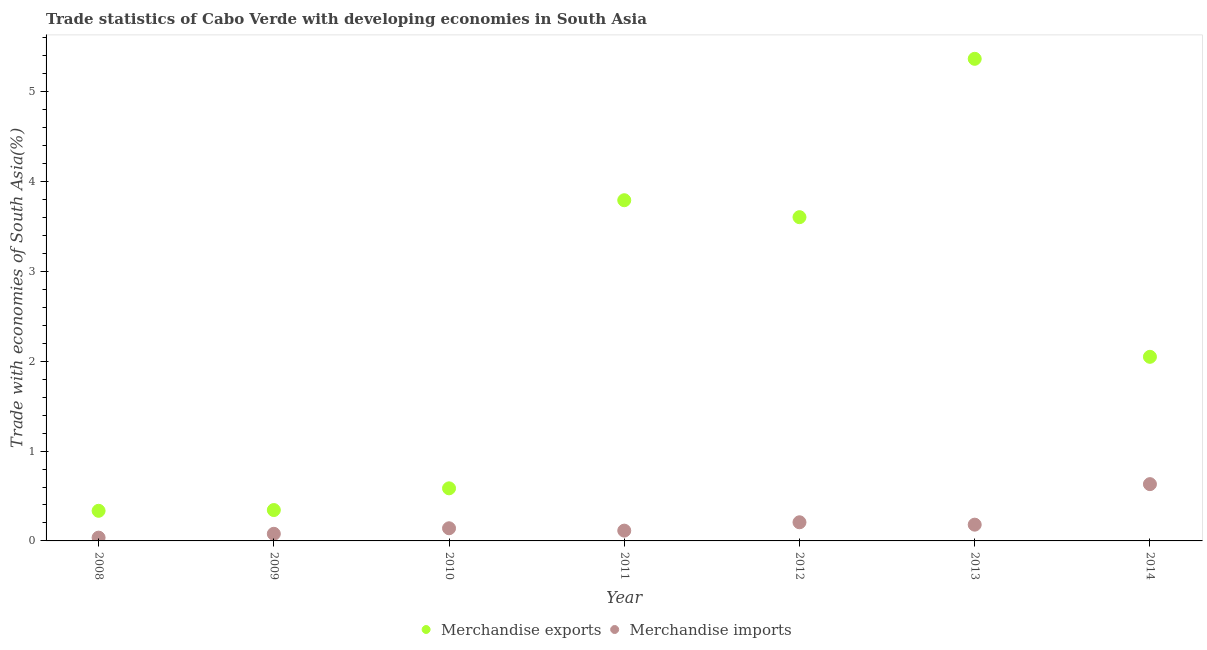What is the merchandise imports in 2014?
Keep it short and to the point. 0.63. Across all years, what is the maximum merchandise exports?
Offer a terse response. 5.37. Across all years, what is the minimum merchandise imports?
Make the answer very short. 0.04. In which year was the merchandise imports minimum?
Make the answer very short. 2008. What is the total merchandise exports in the graph?
Your answer should be very brief. 16.08. What is the difference between the merchandise imports in 2008 and that in 2012?
Offer a terse response. -0.17. What is the difference between the merchandise exports in 2014 and the merchandise imports in 2009?
Give a very brief answer. 1.97. What is the average merchandise exports per year?
Provide a succinct answer. 2.3. In the year 2011, what is the difference between the merchandise exports and merchandise imports?
Offer a very short reply. 3.68. In how many years, is the merchandise exports greater than 3.4 %?
Give a very brief answer. 3. What is the ratio of the merchandise exports in 2008 to that in 2009?
Make the answer very short. 0.98. What is the difference between the highest and the second highest merchandise imports?
Your answer should be compact. 0.42. What is the difference between the highest and the lowest merchandise exports?
Offer a terse response. 5.03. Is the sum of the merchandise exports in 2009 and 2014 greater than the maximum merchandise imports across all years?
Make the answer very short. Yes. Is the merchandise imports strictly greater than the merchandise exports over the years?
Your answer should be compact. No. Is the merchandise exports strictly less than the merchandise imports over the years?
Keep it short and to the point. No. Are the values on the major ticks of Y-axis written in scientific E-notation?
Offer a very short reply. No. Does the graph contain any zero values?
Ensure brevity in your answer.  No. Does the graph contain grids?
Your answer should be very brief. No. Where does the legend appear in the graph?
Provide a short and direct response. Bottom center. How many legend labels are there?
Offer a very short reply. 2. How are the legend labels stacked?
Provide a short and direct response. Horizontal. What is the title of the graph?
Your answer should be compact. Trade statistics of Cabo Verde with developing economies in South Asia. What is the label or title of the Y-axis?
Your response must be concise. Trade with economies of South Asia(%). What is the Trade with economies of South Asia(%) of Merchandise exports in 2008?
Keep it short and to the point. 0.34. What is the Trade with economies of South Asia(%) in Merchandise imports in 2008?
Your response must be concise. 0.04. What is the Trade with economies of South Asia(%) in Merchandise exports in 2009?
Provide a short and direct response. 0.34. What is the Trade with economies of South Asia(%) in Merchandise imports in 2009?
Give a very brief answer. 0.08. What is the Trade with economies of South Asia(%) in Merchandise exports in 2010?
Your answer should be very brief. 0.59. What is the Trade with economies of South Asia(%) in Merchandise imports in 2010?
Give a very brief answer. 0.14. What is the Trade with economies of South Asia(%) in Merchandise exports in 2011?
Offer a very short reply. 3.79. What is the Trade with economies of South Asia(%) of Merchandise imports in 2011?
Make the answer very short. 0.11. What is the Trade with economies of South Asia(%) in Merchandise exports in 2012?
Your response must be concise. 3.6. What is the Trade with economies of South Asia(%) in Merchandise imports in 2012?
Your answer should be very brief. 0.21. What is the Trade with economies of South Asia(%) of Merchandise exports in 2013?
Your answer should be very brief. 5.37. What is the Trade with economies of South Asia(%) in Merchandise imports in 2013?
Provide a short and direct response. 0.18. What is the Trade with economies of South Asia(%) in Merchandise exports in 2014?
Your response must be concise. 2.05. What is the Trade with economies of South Asia(%) of Merchandise imports in 2014?
Offer a very short reply. 0.63. Across all years, what is the maximum Trade with economies of South Asia(%) in Merchandise exports?
Provide a short and direct response. 5.37. Across all years, what is the maximum Trade with economies of South Asia(%) in Merchandise imports?
Your answer should be compact. 0.63. Across all years, what is the minimum Trade with economies of South Asia(%) in Merchandise exports?
Give a very brief answer. 0.34. Across all years, what is the minimum Trade with economies of South Asia(%) of Merchandise imports?
Your answer should be compact. 0.04. What is the total Trade with economies of South Asia(%) in Merchandise exports in the graph?
Give a very brief answer. 16.08. What is the total Trade with economies of South Asia(%) of Merchandise imports in the graph?
Give a very brief answer. 1.39. What is the difference between the Trade with economies of South Asia(%) in Merchandise exports in 2008 and that in 2009?
Provide a short and direct response. -0.01. What is the difference between the Trade with economies of South Asia(%) of Merchandise imports in 2008 and that in 2009?
Offer a very short reply. -0.04. What is the difference between the Trade with economies of South Asia(%) of Merchandise imports in 2008 and that in 2010?
Your answer should be compact. -0.1. What is the difference between the Trade with economies of South Asia(%) of Merchandise exports in 2008 and that in 2011?
Keep it short and to the point. -3.46. What is the difference between the Trade with economies of South Asia(%) of Merchandise imports in 2008 and that in 2011?
Keep it short and to the point. -0.08. What is the difference between the Trade with economies of South Asia(%) in Merchandise exports in 2008 and that in 2012?
Provide a succinct answer. -3.27. What is the difference between the Trade with economies of South Asia(%) in Merchandise imports in 2008 and that in 2012?
Keep it short and to the point. -0.17. What is the difference between the Trade with economies of South Asia(%) of Merchandise exports in 2008 and that in 2013?
Your response must be concise. -5.03. What is the difference between the Trade with economies of South Asia(%) in Merchandise imports in 2008 and that in 2013?
Provide a short and direct response. -0.14. What is the difference between the Trade with economies of South Asia(%) of Merchandise exports in 2008 and that in 2014?
Make the answer very short. -1.71. What is the difference between the Trade with economies of South Asia(%) in Merchandise imports in 2008 and that in 2014?
Keep it short and to the point. -0.6. What is the difference between the Trade with economies of South Asia(%) in Merchandise exports in 2009 and that in 2010?
Offer a very short reply. -0.24. What is the difference between the Trade with economies of South Asia(%) of Merchandise imports in 2009 and that in 2010?
Your answer should be very brief. -0.06. What is the difference between the Trade with economies of South Asia(%) of Merchandise exports in 2009 and that in 2011?
Your answer should be compact. -3.45. What is the difference between the Trade with economies of South Asia(%) in Merchandise imports in 2009 and that in 2011?
Make the answer very short. -0.04. What is the difference between the Trade with economies of South Asia(%) in Merchandise exports in 2009 and that in 2012?
Your answer should be very brief. -3.26. What is the difference between the Trade with economies of South Asia(%) in Merchandise imports in 2009 and that in 2012?
Give a very brief answer. -0.13. What is the difference between the Trade with economies of South Asia(%) of Merchandise exports in 2009 and that in 2013?
Keep it short and to the point. -5.02. What is the difference between the Trade with economies of South Asia(%) in Merchandise imports in 2009 and that in 2013?
Make the answer very short. -0.1. What is the difference between the Trade with economies of South Asia(%) in Merchandise exports in 2009 and that in 2014?
Ensure brevity in your answer.  -1.71. What is the difference between the Trade with economies of South Asia(%) in Merchandise imports in 2009 and that in 2014?
Provide a short and direct response. -0.55. What is the difference between the Trade with economies of South Asia(%) of Merchandise exports in 2010 and that in 2011?
Your response must be concise. -3.21. What is the difference between the Trade with economies of South Asia(%) in Merchandise imports in 2010 and that in 2011?
Provide a short and direct response. 0.03. What is the difference between the Trade with economies of South Asia(%) in Merchandise exports in 2010 and that in 2012?
Offer a very short reply. -3.02. What is the difference between the Trade with economies of South Asia(%) in Merchandise imports in 2010 and that in 2012?
Provide a short and direct response. -0.07. What is the difference between the Trade with economies of South Asia(%) of Merchandise exports in 2010 and that in 2013?
Your answer should be compact. -4.78. What is the difference between the Trade with economies of South Asia(%) of Merchandise imports in 2010 and that in 2013?
Your answer should be very brief. -0.04. What is the difference between the Trade with economies of South Asia(%) of Merchandise exports in 2010 and that in 2014?
Provide a succinct answer. -1.46. What is the difference between the Trade with economies of South Asia(%) in Merchandise imports in 2010 and that in 2014?
Your response must be concise. -0.49. What is the difference between the Trade with economies of South Asia(%) in Merchandise exports in 2011 and that in 2012?
Provide a short and direct response. 0.19. What is the difference between the Trade with economies of South Asia(%) in Merchandise imports in 2011 and that in 2012?
Offer a very short reply. -0.09. What is the difference between the Trade with economies of South Asia(%) in Merchandise exports in 2011 and that in 2013?
Ensure brevity in your answer.  -1.57. What is the difference between the Trade with economies of South Asia(%) of Merchandise imports in 2011 and that in 2013?
Your answer should be compact. -0.07. What is the difference between the Trade with economies of South Asia(%) of Merchandise exports in 2011 and that in 2014?
Ensure brevity in your answer.  1.74. What is the difference between the Trade with economies of South Asia(%) of Merchandise imports in 2011 and that in 2014?
Make the answer very short. -0.52. What is the difference between the Trade with economies of South Asia(%) in Merchandise exports in 2012 and that in 2013?
Offer a very short reply. -1.76. What is the difference between the Trade with economies of South Asia(%) of Merchandise imports in 2012 and that in 2013?
Offer a terse response. 0.03. What is the difference between the Trade with economies of South Asia(%) in Merchandise exports in 2012 and that in 2014?
Your response must be concise. 1.55. What is the difference between the Trade with economies of South Asia(%) of Merchandise imports in 2012 and that in 2014?
Ensure brevity in your answer.  -0.42. What is the difference between the Trade with economies of South Asia(%) of Merchandise exports in 2013 and that in 2014?
Your answer should be very brief. 3.32. What is the difference between the Trade with economies of South Asia(%) of Merchandise imports in 2013 and that in 2014?
Offer a terse response. -0.45. What is the difference between the Trade with economies of South Asia(%) in Merchandise exports in 2008 and the Trade with economies of South Asia(%) in Merchandise imports in 2009?
Provide a short and direct response. 0.26. What is the difference between the Trade with economies of South Asia(%) of Merchandise exports in 2008 and the Trade with economies of South Asia(%) of Merchandise imports in 2010?
Ensure brevity in your answer.  0.19. What is the difference between the Trade with economies of South Asia(%) of Merchandise exports in 2008 and the Trade with economies of South Asia(%) of Merchandise imports in 2011?
Provide a short and direct response. 0.22. What is the difference between the Trade with economies of South Asia(%) in Merchandise exports in 2008 and the Trade with economies of South Asia(%) in Merchandise imports in 2012?
Your answer should be very brief. 0.13. What is the difference between the Trade with economies of South Asia(%) in Merchandise exports in 2008 and the Trade with economies of South Asia(%) in Merchandise imports in 2013?
Offer a terse response. 0.15. What is the difference between the Trade with economies of South Asia(%) in Merchandise exports in 2008 and the Trade with economies of South Asia(%) in Merchandise imports in 2014?
Your answer should be compact. -0.3. What is the difference between the Trade with economies of South Asia(%) in Merchandise exports in 2009 and the Trade with economies of South Asia(%) in Merchandise imports in 2010?
Your answer should be very brief. 0.2. What is the difference between the Trade with economies of South Asia(%) in Merchandise exports in 2009 and the Trade with economies of South Asia(%) in Merchandise imports in 2011?
Your answer should be very brief. 0.23. What is the difference between the Trade with economies of South Asia(%) of Merchandise exports in 2009 and the Trade with economies of South Asia(%) of Merchandise imports in 2012?
Provide a succinct answer. 0.14. What is the difference between the Trade with economies of South Asia(%) of Merchandise exports in 2009 and the Trade with economies of South Asia(%) of Merchandise imports in 2013?
Offer a terse response. 0.16. What is the difference between the Trade with economies of South Asia(%) in Merchandise exports in 2009 and the Trade with economies of South Asia(%) in Merchandise imports in 2014?
Give a very brief answer. -0.29. What is the difference between the Trade with economies of South Asia(%) of Merchandise exports in 2010 and the Trade with economies of South Asia(%) of Merchandise imports in 2011?
Provide a succinct answer. 0.47. What is the difference between the Trade with economies of South Asia(%) of Merchandise exports in 2010 and the Trade with economies of South Asia(%) of Merchandise imports in 2012?
Provide a short and direct response. 0.38. What is the difference between the Trade with economies of South Asia(%) in Merchandise exports in 2010 and the Trade with economies of South Asia(%) in Merchandise imports in 2013?
Provide a succinct answer. 0.4. What is the difference between the Trade with economies of South Asia(%) of Merchandise exports in 2010 and the Trade with economies of South Asia(%) of Merchandise imports in 2014?
Ensure brevity in your answer.  -0.05. What is the difference between the Trade with economies of South Asia(%) of Merchandise exports in 2011 and the Trade with economies of South Asia(%) of Merchandise imports in 2012?
Your answer should be compact. 3.58. What is the difference between the Trade with economies of South Asia(%) of Merchandise exports in 2011 and the Trade with economies of South Asia(%) of Merchandise imports in 2013?
Ensure brevity in your answer.  3.61. What is the difference between the Trade with economies of South Asia(%) of Merchandise exports in 2011 and the Trade with economies of South Asia(%) of Merchandise imports in 2014?
Give a very brief answer. 3.16. What is the difference between the Trade with economies of South Asia(%) in Merchandise exports in 2012 and the Trade with economies of South Asia(%) in Merchandise imports in 2013?
Keep it short and to the point. 3.42. What is the difference between the Trade with economies of South Asia(%) in Merchandise exports in 2012 and the Trade with economies of South Asia(%) in Merchandise imports in 2014?
Offer a terse response. 2.97. What is the difference between the Trade with economies of South Asia(%) of Merchandise exports in 2013 and the Trade with economies of South Asia(%) of Merchandise imports in 2014?
Offer a terse response. 4.73. What is the average Trade with economies of South Asia(%) in Merchandise exports per year?
Your response must be concise. 2.3. What is the average Trade with economies of South Asia(%) in Merchandise imports per year?
Give a very brief answer. 0.2. In the year 2008, what is the difference between the Trade with economies of South Asia(%) in Merchandise exports and Trade with economies of South Asia(%) in Merchandise imports?
Offer a very short reply. 0.3. In the year 2009, what is the difference between the Trade with economies of South Asia(%) in Merchandise exports and Trade with economies of South Asia(%) in Merchandise imports?
Give a very brief answer. 0.26. In the year 2010, what is the difference between the Trade with economies of South Asia(%) in Merchandise exports and Trade with economies of South Asia(%) in Merchandise imports?
Make the answer very short. 0.44. In the year 2011, what is the difference between the Trade with economies of South Asia(%) in Merchandise exports and Trade with economies of South Asia(%) in Merchandise imports?
Your answer should be compact. 3.68. In the year 2012, what is the difference between the Trade with economies of South Asia(%) in Merchandise exports and Trade with economies of South Asia(%) in Merchandise imports?
Ensure brevity in your answer.  3.4. In the year 2013, what is the difference between the Trade with economies of South Asia(%) of Merchandise exports and Trade with economies of South Asia(%) of Merchandise imports?
Make the answer very short. 5.19. In the year 2014, what is the difference between the Trade with economies of South Asia(%) of Merchandise exports and Trade with economies of South Asia(%) of Merchandise imports?
Keep it short and to the point. 1.42. What is the ratio of the Trade with economies of South Asia(%) of Merchandise exports in 2008 to that in 2009?
Your response must be concise. 0.98. What is the ratio of the Trade with economies of South Asia(%) of Merchandise imports in 2008 to that in 2009?
Give a very brief answer. 0.46. What is the ratio of the Trade with economies of South Asia(%) in Merchandise exports in 2008 to that in 2010?
Provide a succinct answer. 0.57. What is the ratio of the Trade with economies of South Asia(%) in Merchandise imports in 2008 to that in 2010?
Provide a short and direct response. 0.26. What is the ratio of the Trade with economies of South Asia(%) of Merchandise exports in 2008 to that in 2011?
Give a very brief answer. 0.09. What is the ratio of the Trade with economies of South Asia(%) in Merchandise imports in 2008 to that in 2011?
Offer a very short reply. 0.32. What is the ratio of the Trade with economies of South Asia(%) in Merchandise exports in 2008 to that in 2012?
Give a very brief answer. 0.09. What is the ratio of the Trade with economies of South Asia(%) of Merchandise imports in 2008 to that in 2012?
Your response must be concise. 0.18. What is the ratio of the Trade with economies of South Asia(%) in Merchandise exports in 2008 to that in 2013?
Your answer should be very brief. 0.06. What is the ratio of the Trade with economies of South Asia(%) of Merchandise imports in 2008 to that in 2013?
Provide a succinct answer. 0.2. What is the ratio of the Trade with economies of South Asia(%) in Merchandise exports in 2008 to that in 2014?
Ensure brevity in your answer.  0.16. What is the ratio of the Trade with economies of South Asia(%) in Merchandise imports in 2008 to that in 2014?
Offer a terse response. 0.06. What is the ratio of the Trade with economies of South Asia(%) of Merchandise exports in 2009 to that in 2010?
Your response must be concise. 0.59. What is the ratio of the Trade with economies of South Asia(%) in Merchandise imports in 2009 to that in 2010?
Your answer should be compact. 0.56. What is the ratio of the Trade with economies of South Asia(%) of Merchandise exports in 2009 to that in 2011?
Offer a very short reply. 0.09. What is the ratio of the Trade with economies of South Asia(%) in Merchandise imports in 2009 to that in 2011?
Offer a very short reply. 0.69. What is the ratio of the Trade with economies of South Asia(%) in Merchandise exports in 2009 to that in 2012?
Ensure brevity in your answer.  0.1. What is the ratio of the Trade with economies of South Asia(%) in Merchandise imports in 2009 to that in 2012?
Keep it short and to the point. 0.38. What is the ratio of the Trade with economies of South Asia(%) of Merchandise exports in 2009 to that in 2013?
Provide a short and direct response. 0.06. What is the ratio of the Trade with economies of South Asia(%) in Merchandise imports in 2009 to that in 2013?
Ensure brevity in your answer.  0.44. What is the ratio of the Trade with economies of South Asia(%) in Merchandise exports in 2009 to that in 2014?
Provide a succinct answer. 0.17. What is the ratio of the Trade with economies of South Asia(%) in Merchandise imports in 2009 to that in 2014?
Ensure brevity in your answer.  0.13. What is the ratio of the Trade with economies of South Asia(%) in Merchandise exports in 2010 to that in 2011?
Provide a succinct answer. 0.15. What is the ratio of the Trade with economies of South Asia(%) of Merchandise imports in 2010 to that in 2011?
Provide a short and direct response. 1.23. What is the ratio of the Trade with economies of South Asia(%) of Merchandise exports in 2010 to that in 2012?
Provide a short and direct response. 0.16. What is the ratio of the Trade with economies of South Asia(%) in Merchandise imports in 2010 to that in 2012?
Provide a short and direct response. 0.68. What is the ratio of the Trade with economies of South Asia(%) of Merchandise exports in 2010 to that in 2013?
Your answer should be very brief. 0.11. What is the ratio of the Trade with economies of South Asia(%) of Merchandise imports in 2010 to that in 2013?
Offer a terse response. 0.78. What is the ratio of the Trade with economies of South Asia(%) of Merchandise exports in 2010 to that in 2014?
Offer a terse response. 0.29. What is the ratio of the Trade with economies of South Asia(%) in Merchandise imports in 2010 to that in 2014?
Give a very brief answer. 0.22. What is the ratio of the Trade with economies of South Asia(%) in Merchandise exports in 2011 to that in 2012?
Your answer should be very brief. 1.05. What is the ratio of the Trade with economies of South Asia(%) of Merchandise imports in 2011 to that in 2012?
Offer a terse response. 0.55. What is the ratio of the Trade with economies of South Asia(%) of Merchandise exports in 2011 to that in 2013?
Keep it short and to the point. 0.71. What is the ratio of the Trade with economies of South Asia(%) of Merchandise imports in 2011 to that in 2013?
Offer a terse response. 0.63. What is the ratio of the Trade with economies of South Asia(%) of Merchandise exports in 2011 to that in 2014?
Provide a short and direct response. 1.85. What is the ratio of the Trade with economies of South Asia(%) in Merchandise imports in 2011 to that in 2014?
Offer a terse response. 0.18. What is the ratio of the Trade with economies of South Asia(%) in Merchandise exports in 2012 to that in 2013?
Provide a succinct answer. 0.67. What is the ratio of the Trade with economies of South Asia(%) in Merchandise imports in 2012 to that in 2013?
Offer a terse response. 1.15. What is the ratio of the Trade with economies of South Asia(%) of Merchandise exports in 2012 to that in 2014?
Offer a very short reply. 1.76. What is the ratio of the Trade with economies of South Asia(%) in Merchandise imports in 2012 to that in 2014?
Keep it short and to the point. 0.33. What is the ratio of the Trade with economies of South Asia(%) in Merchandise exports in 2013 to that in 2014?
Provide a short and direct response. 2.62. What is the ratio of the Trade with economies of South Asia(%) of Merchandise imports in 2013 to that in 2014?
Give a very brief answer. 0.29. What is the difference between the highest and the second highest Trade with economies of South Asia(%) in Merchandise exports?
Provide a succinct answer. 1.57. What is the difference between the highest and the second highest Trade with economies of South Asia(%) of Merchandise imports?
Your response must be concise. 0.42. What is the difference between the highest and the lowest Trade with economies of South Asia(%) in Merchandise exports?
Your answer should be very brief. 5.03. What is the difference between the highest and the lowest Trade with economies of South Asia(%) in Merchandise imports?
Your answer should be very brief. 0.6. 